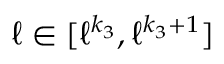<formula> <loc_0><loc_0><loc_500><loc_500>\ell \in [ \ell ^ { k _ { 3 } } , \ell ^ { k _ { 3 } + 1 } ]</formula> 